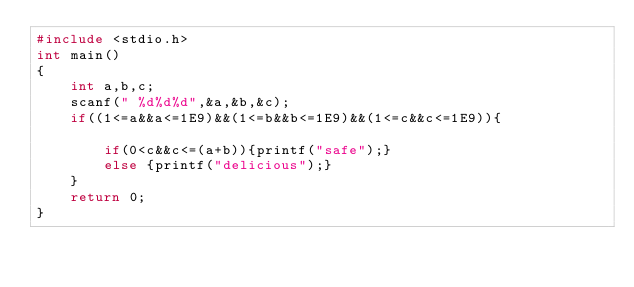<code> <loc_0><loc_0><loc_500><loc_500><_C_>#include <stdio.h>
int main()
{
    int a,b,c;
    scanf(" %d%d%d",&a,&b,&c);
    if((1<=a&&a<=1E9)&&(1<=b&&b<=1E9)&&(1<=c&&c<=1E9)){

        if(0<c&&c<=(a+b)){printf("safe");}
        else {printf("delicious");}
    }
    return 0;
}
</code> 